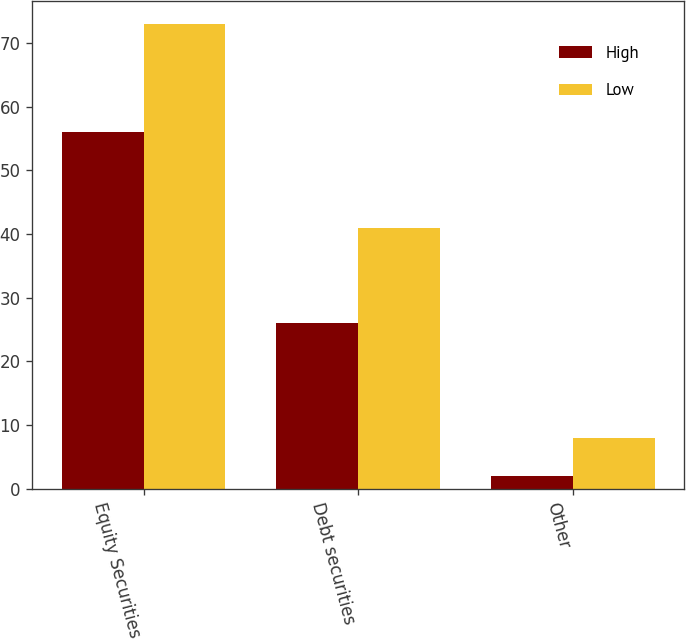Convert chart to OTSL. <chart><loc_0><loc_0><loc_500><loc_500><stacked_bar_chart><ecel><fcel>Equity Securities<fcel>Debt securities<fcel>Other<nl><fcel>High<fcel>56<fcel>26<fcel>2<nl><fcel>Low<fcel>73<fcel>41<fcel>8<nl></chart> 